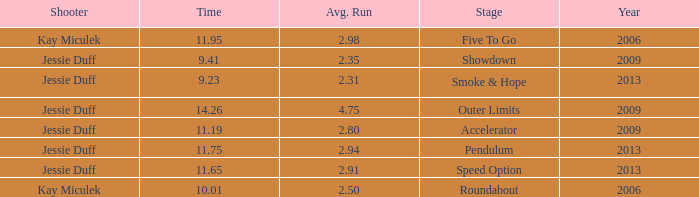What is the total amount of time for years prior to 2013 when speed option is the stage? None. 